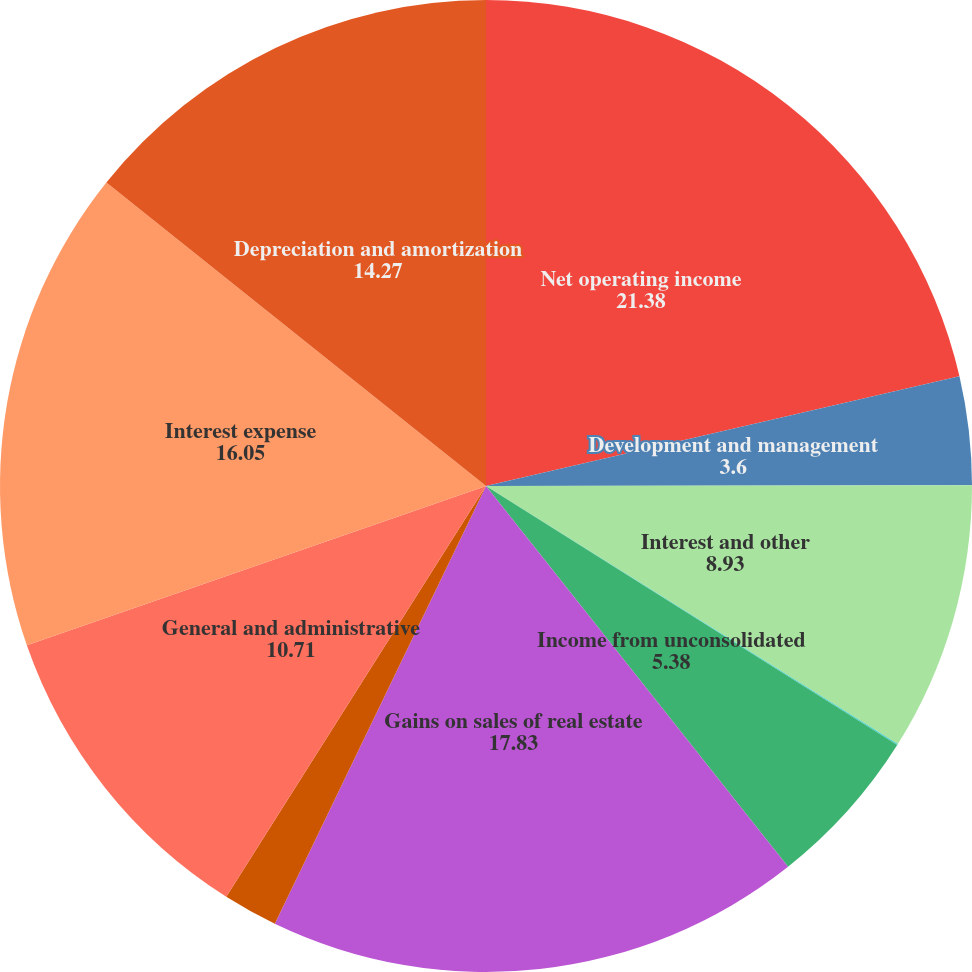<chart> <loc_0><loc_0><loc_500><loc_500><pie_chart><fcel>Net operating income<fcel>Development and management<fcel>Interest and other<fcel>Minority interests in property<fcel>Income from unconsolidated<fcel>Gains on sales of real estate<fcel>Income from discontinued<fcel>General and administrative<fcel>Interest expense<fcel>Depreciation and amortization<nl><fcel>21.38%<fcel>3.6%<fcel>8.93%<fcel>0.04%<fcel>5.38%<fcel>17.83%<fcel>1.82%<fcel>10.71%<fcel>16.05%<fcel>14.27%<nl></chart> 